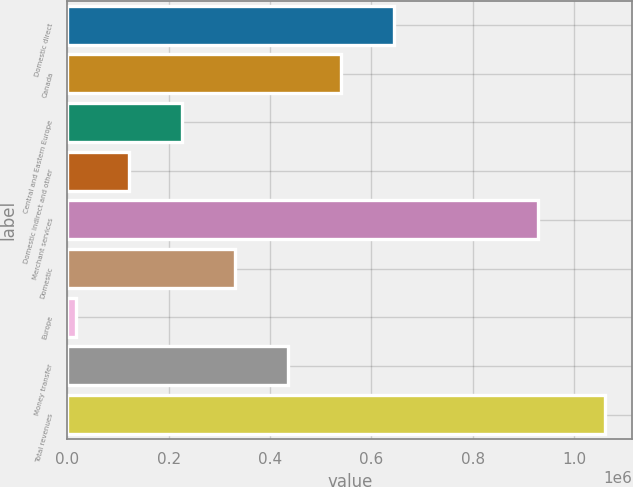Convert chart to OTSL. <chart><loc_0><loc_0><loc_500><loc_500><bar_chart><fcel>Domestic direct<fcel>Canada<fcel>Central and Eastern Europe<fcel>Domestic indirect and other<fcel>Merchant services<fcel>Domestic<fcel>Europe<fcel>Money transfer<fcel>Total revenues<nl><fcel>643700<fcel>539244<fcel>225877<fcel>121421<fcel>929142<fcel>330332<fcel>16965<fcel>434788<fcel>1.06152e+06<nl></chart> 